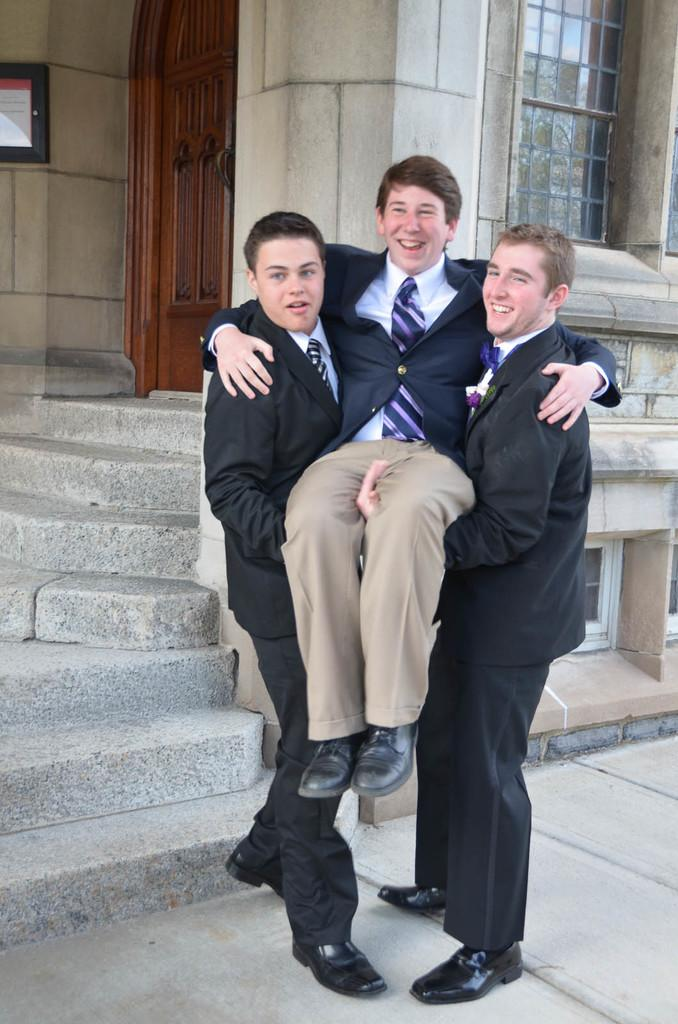How many people are in the image? There are a few people in the image. What can be seen under the people's feet? The ground is visible in the image. Are there any architectural features in the image? Yes, there are stairs in the image. What is on the wall in the image? There is a wall with windows in the image. Is there any entrance or exit in the image? Yes, there is a door in the image. What is on the left side of the image? There is a board on the left side of the image. Can you tell me how many engines are visible in the image? There are no engines present in the image. What type of battle is taking place in the image? There is no battle depicted in the image; it features people, stairs, a wall with windows, a door, and a board. 